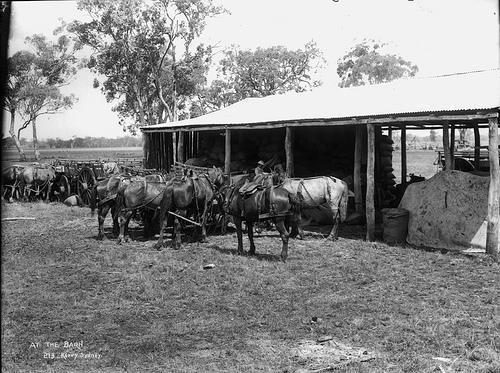How many horses are there?
Give a very brief answer. 3. 